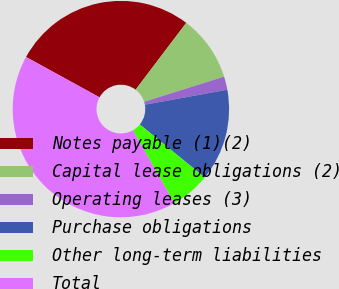<chart> <loc_0><loc_0><loc_500><loc_500><pie_chart><fcel>Notes payable (1)(2)<fcel>Capital lease obligations (2)<fcel>Operating leases (3)<fcel>Purchase obligations<fcel>Other long-term liabilities<fcel>Total<nl><fcel>27.33%<fcel>9.83%<fcel>1.98%<fcel>13.75%<fcel>5.9%<fcel>41.22%<nl></chart> 